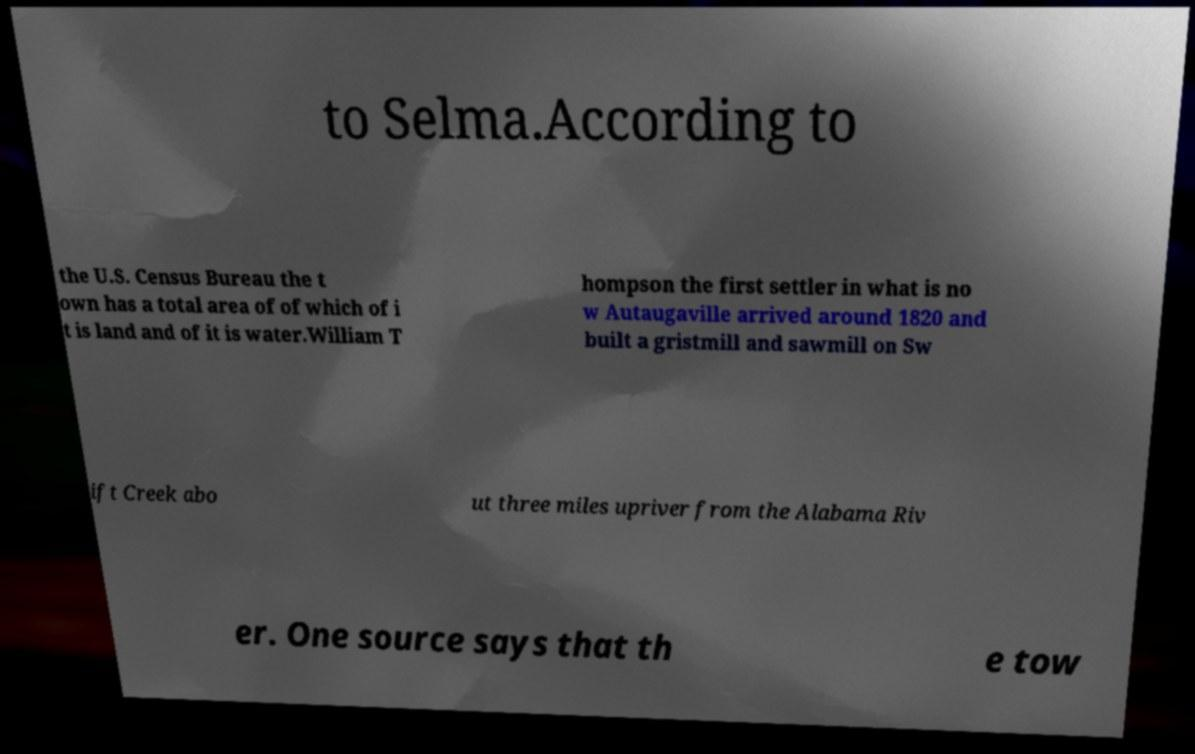I need the written content from this picture converted into text. Can you do that? to Selma.According to the U.S. Census Bureau the t own has a total area of of which of i t is land and of it is water.William T hompson the first settler in what is no w Autaugaville arrived around 1820 and built a gristmill and sawmill on Sw ift Creek abo ut three miles upriver from the Alabama Riv er. One source says that th e tow 